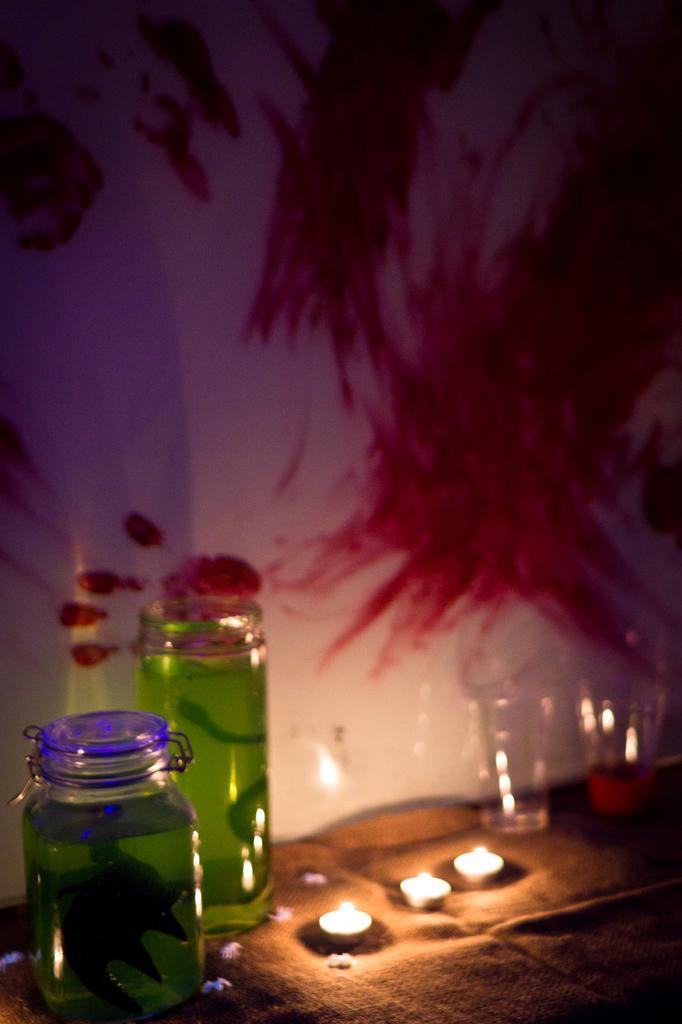How would you summarize this image in a sentence or two? In this picture we can see a jar with liquid and leaf in it and aside to this we have a glass bottle with same liquid in it and on right side we have two glasses and in middle we have three candles and this are placed on a table and in the background we can see wall with pink color painting and hand symbol. 